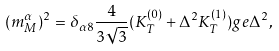<formula> <loc_0><loc_0><loc_500><loc_500>( m _ { M } ^ { \alpha } ) ^ { 2 } = \delta _ { \alpha 8 } \frac { 4 } { 3 \sqrt { 3 } } ( K _ { T } ^ { ( 0 ) } + \Delta ^ { 2 } K _ { T } ^ { ( 1 ) } ) g e \Delta ^ { 2 } ,</formula> 